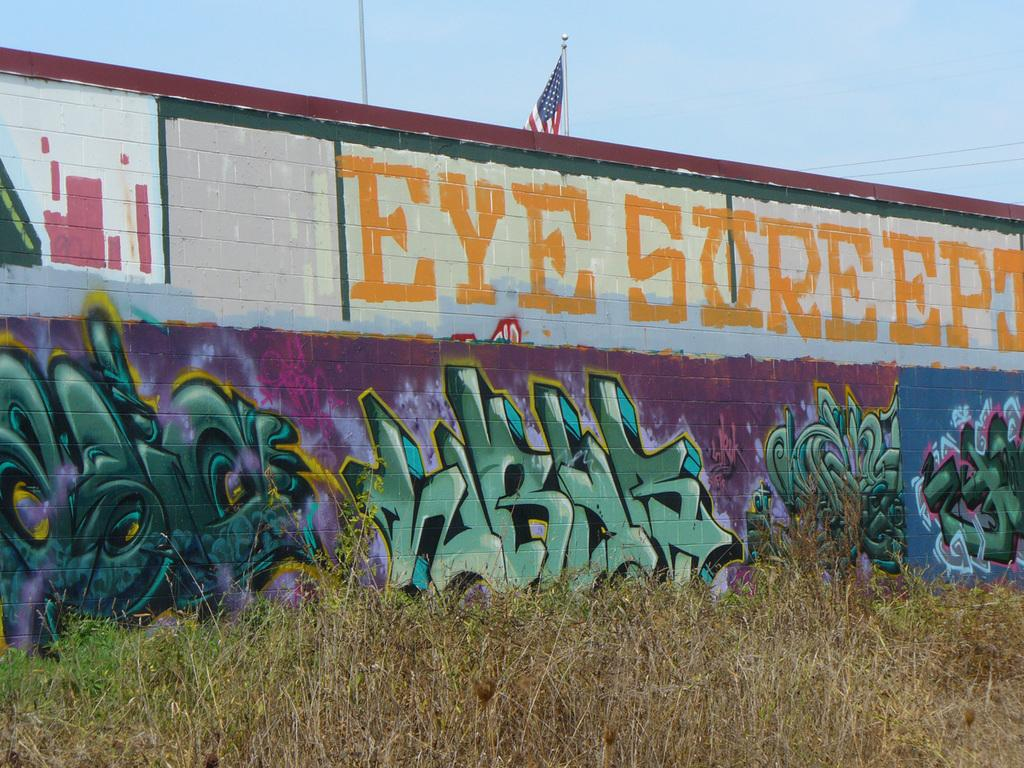What is the main structure visible in the image? There is a wall in the image. What is depicted on the wall? The wall has a graffiti painting on it. What type of vegetation is at the bottom of the image? There is grass at the bottom of the image. What is visible at the top of the image? The sky is visible at the top of the image. What additional element can be seen in the image? There is a flag in the image. What type of teeth can be seen in the graffiti painting on the wall? There are no teeth visible in the graffiti painting on the wall. 